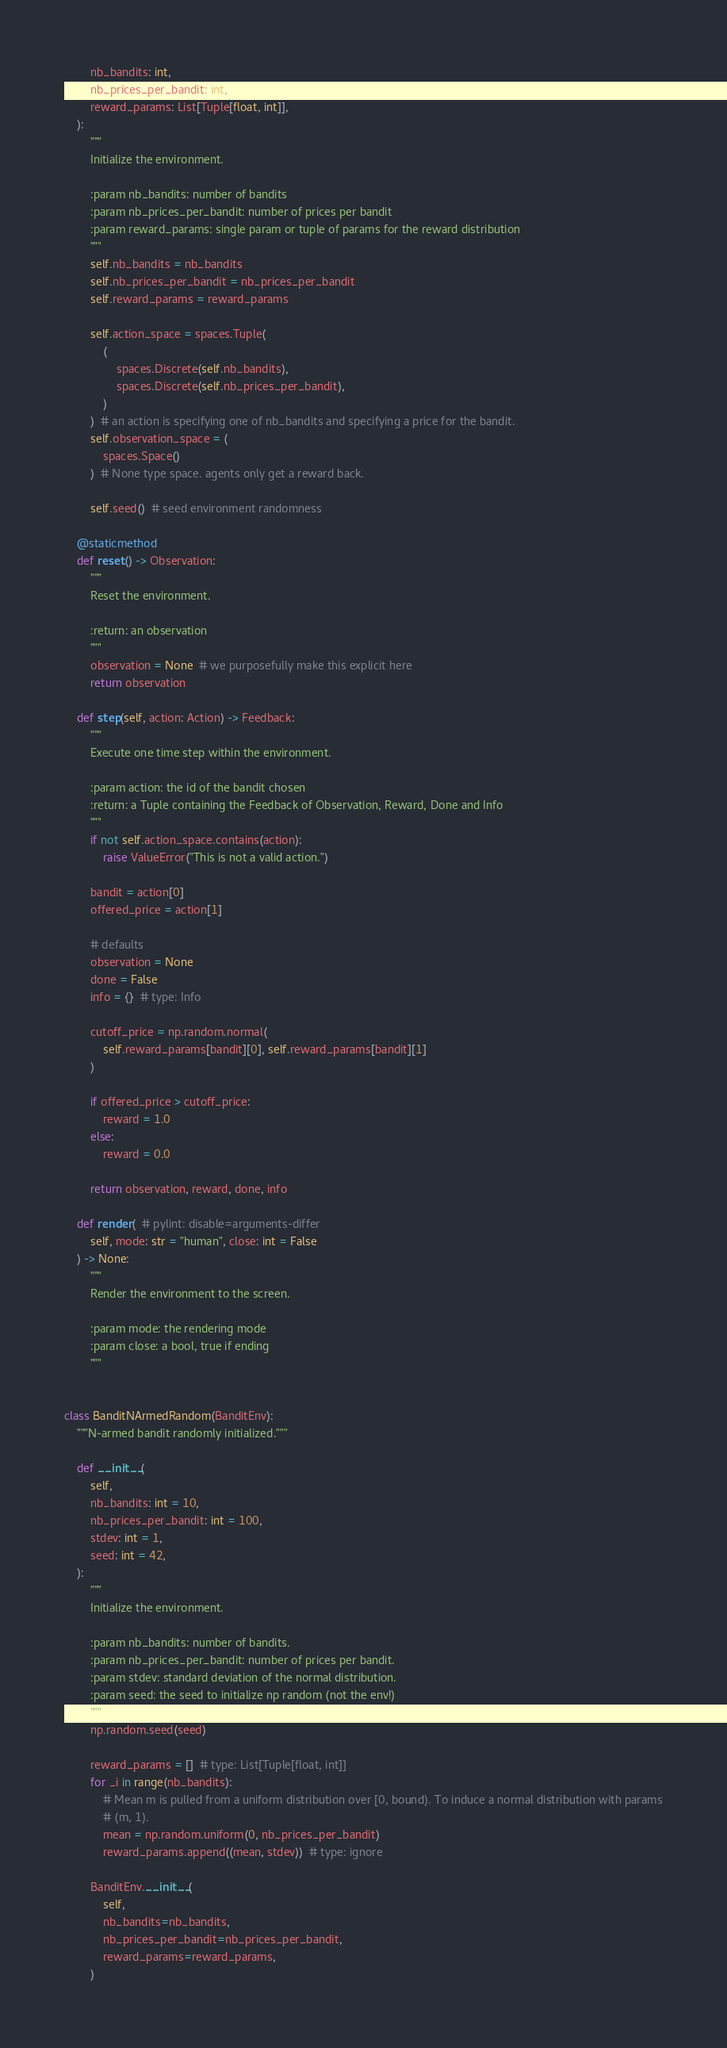<code> <loc_0><loc_0><loc_500><loc_500><_Python_>        nb_bandits: int,
        nb_prices_per_bandit: int,
        reward_params: List[Tuple[float, int]],
    ):
        """
        Initialize the environment.

        :param nb_bandits: number of bandits
        :param nb_prices_per_bandit: number of prices per bandit
        :param reward_params: single param or tuple of params for the reward distribution
        """
        self.nb_bandits = nb_bandits
        self.nb_prices_per_bandit = nb_prices_per_bandit
        self.reward_params = reward_params

        self.action_space = spaces.Tuple(
            (
                spaces.Discrete(self.nb_bandits),
                spaces.Discrete(self.nb_prices_per_bandit),
            )
        )  # an action is specifying one of nb_bandits and specifying a price for the bandit.
        self.observation_space = (
            spaces.Space()
        )  # None type space. agents only get a reward back.

        self.seed()  # seed environment randomness

    @staticmethod
    def reset() -> Observation:
        """
        Reset the environment.

        :return: an observation
        """
        observation = None  # we purposefully make this explicit here
        return observation

    def step(self, action: Action) -> Feedback:
        """
        Execute one time step within the environment.

        :param action: the id of the bandit chosen
        :return: a Tuple containing the Feedback of Observation, Reward, Done and Info
        """
        if not self.action_space.contains(action):
            raise ValueError("This is not a valid action.")

        bandit = action[0]
        offered_price = action[1]

        # defaults
        observation = None
        done = False
        info = {}  # type: Info

        cutoff_price = np.random.normal(
            self.reward_params[bandit][0], self.reward_params[bandit][1]
        )

        if offered_price > cutoff_price:
            reward = 1.0
        else:
            reward = 0.0

        return observation, reward, done, info

    def render(  # pylint: disable=arguments-differ
        self, mode: str = "human", close: int = False
    ) -> None:
        """
        Render the environment to the screen.

        :param mode: the rendering mode
        :param close: a bool, true if ending
        """


class BanditNArmedRandom(BanditEnv):
    """N-armed bandit randomly initialized."""

    def __init__(
        self,
        nb_bandits: int = 10,
        nb_prices_per_bandit: int = 100,
        stdev: int = 1,
        seed: int = 42,
    ):
        """
        Initialize the environment.

        :param nb_bandits: number of bandits.
        :param nb_prices_per_bandit: number of prices per bandit.
        :param stdev: standard deviation of the normal distribution.
        :param seed: the seed to initialize np random (not the env!)
        """
        np.random.seed(seed)

        reward_params = []  # type: List[Tuple[float, int]]
        for _i in range(nb_bandits):
            # Mean m is pulled from a uniform distribution over [0, bound). To induce a normal distribution with params
            # (m, 1).
            mean = np.random.uniform(0, nb_prices_per_bandit)
            reward_params.append((mean, stdev))  # type: ignore

        BanditEnv.__init__(
            self,
            nb_bandits=nb_bandits,
            nb_prices_per_bandit=nb_prices_per_bandit,
            reward_params=reward_params,
        )
</code> 